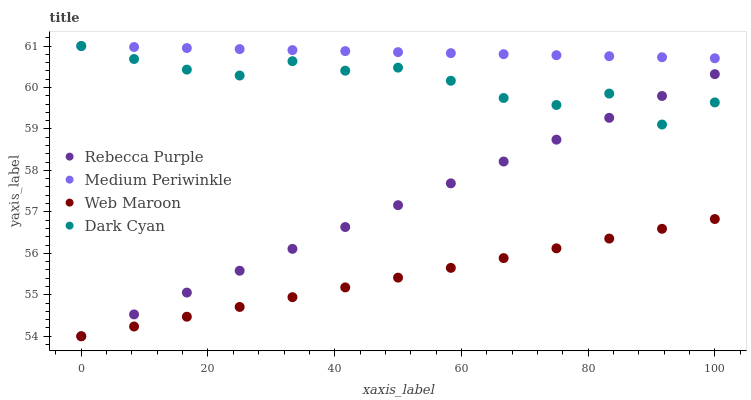Does Web Maroon have the minimum area under the curve?
Answer yes or no. Yes. Does Medium Periwinkle have the maximum area under the curve?
Answer yes or no. Yes. Does Medium Periwinkle have the minimum area under the curve?
Answer yes or no. No. Does Web Maroon have the maximum area under the curve?
Answer yes or no. No. Is Medium Periwinkle the smoothest?
Answer yes or no. Yes. Is Dark Cyan the roughest?
Answer yes or no. Yes. Is Web Maroon the smoothest?
Answer yes or no. No. Is Web Maroon the roughest?
Answer yes or no. No. Does Web Maroon have the lowest value?
Answer yes or no. Yes. Does Medium Periwinkle have the lowest value?
Answer yes or no. No. Does Medium Periwinkle have the highest value?
Answer yes or no. Yes. Does Web Maroon have the highest value?
Answer yes or no. No. Is Web Maroon less than Dark Cyan?
Answer yes or no. Yes. Is Medium Periwinkle greater than Web Maroon?
Answer yes or no. Yes. Does Medium Periwinkle intersect Dark Cyan?
Answer yes or no. Yes. Is Medium Periwinkle less than Dark Cyan?
Answer yes or no. No. Is Medium Periwinkle greater than Dark Cyan?
Answer yes or no. No. Does Web Maroon intersect Dark Cyan?
Answer yes or no. No. 